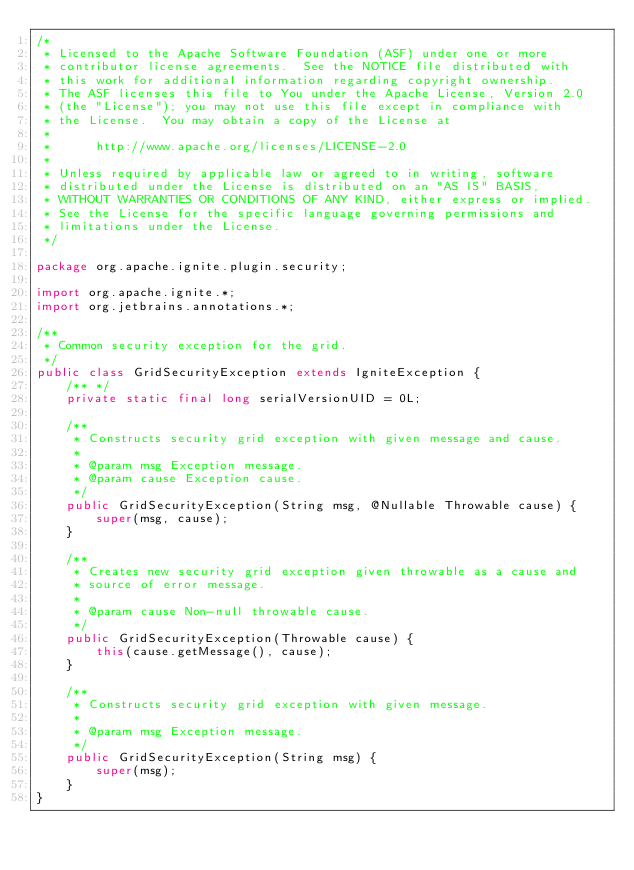<code> <loc_0><loc_0><loc_500><loc_500><_Java_>/*
 * Licensed to the Apache Software Foundation (ASF) under one or more
 * contributor license agreements.  See the NOTICE file distributed with
 * this work for additional information regarding copyright ownership.
 * The ASF licenses this file to You under the Apache License, Version 2.0
 * (the "License"); you may not use this file except in compliance with
 * the License.  You may obtain a copy of the License at
 *
 *      http://www.apache.org/licenses/LICENSE-2.0
 *
 * Unless required by applicable law or agreed to in writing, software
 * distributed under the License is distributed on an "AS IS" BASIS,
 * WITHOUT WARRANTIES OR CONDITIONS OF ANY KIND, either express or implied.
 * See the License for the specific language governing permissions and
 * limitations under the License.
 */

package org.apache.ignite.plugin.security;

import org.apache.ignite.*;
import org.jetbrains.annotations.*;

/**
 * Common security exception for the grid.
 */
public class GridSecurityException extends IgniteException {
    /** */
    private static final long serialVersionUID = 0L;

    /**
     * Constructs security grid exception with given message and cause.
     *
     * @param msg Exception message.
     * @param cause Exception cause.
     */
    public GridSecurityException(String msg, @Nullable Throwable cause) {
        super(msg, cause);
    }

    /**
     * Creates new security grid exception given throwable as a cause and
     * source of error message.
     *
     * @param cause Non-null throwable cause.
     */
    public GridSecurityException(Throwable cause) {
        this(cause.getMessage(), cause);
    }

    /**
     * Constructs security grid exception with given message.
     *
     * @param msg Exception message.
     */
    public GridSecurityException(String msg) {
        super(msg);
    }
}
</code> 